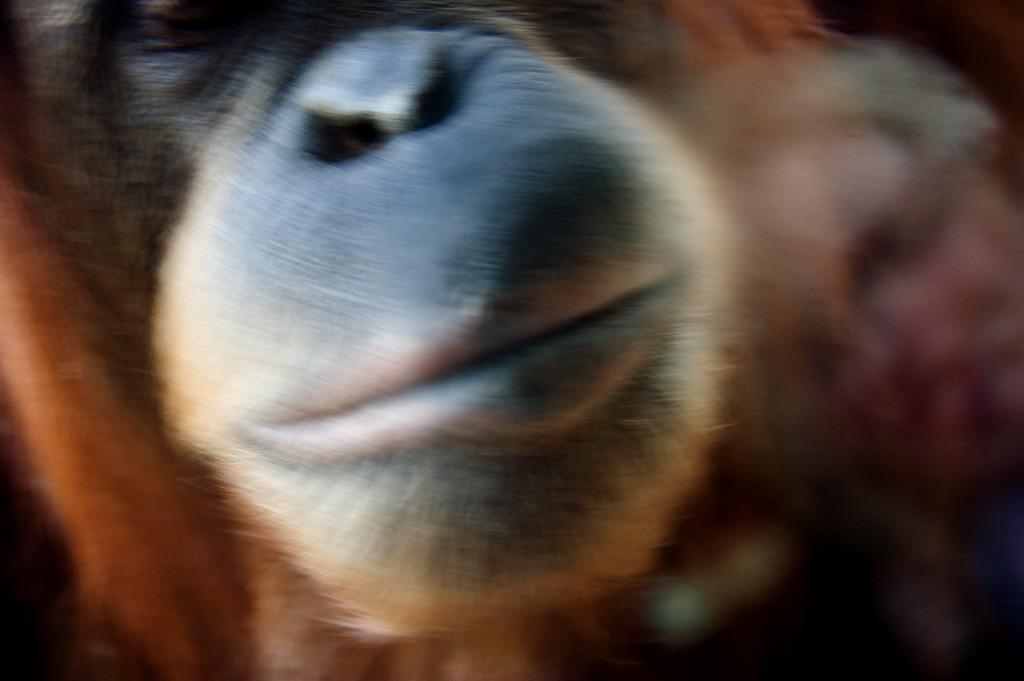What type of living creature is present in the image? There is an animal in the image. What type of boot is being used to prepare the meal in the image? There is no boot or meal present in the image; it only features an animal. What kind of apparatus is being used to interact with the animal in the image? There is no apparatus present in the image; the animal is the only subject mentioned in the provided fact. 